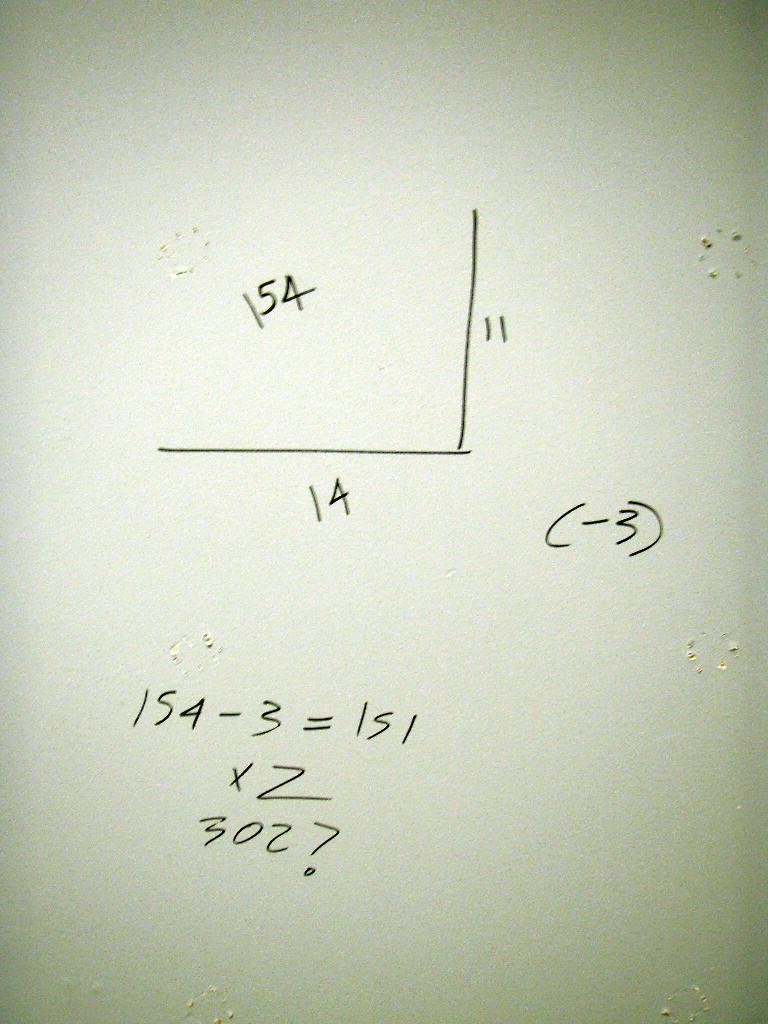Can you describe this image briefly? In this image there are some numbers and lines. 